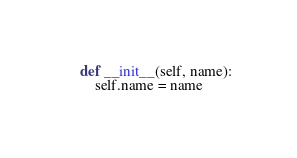<code> <loc_0><loc_0><loc_500><loc_500><_Python_>    def __init__(self, name):
        self.name = name
</code> 